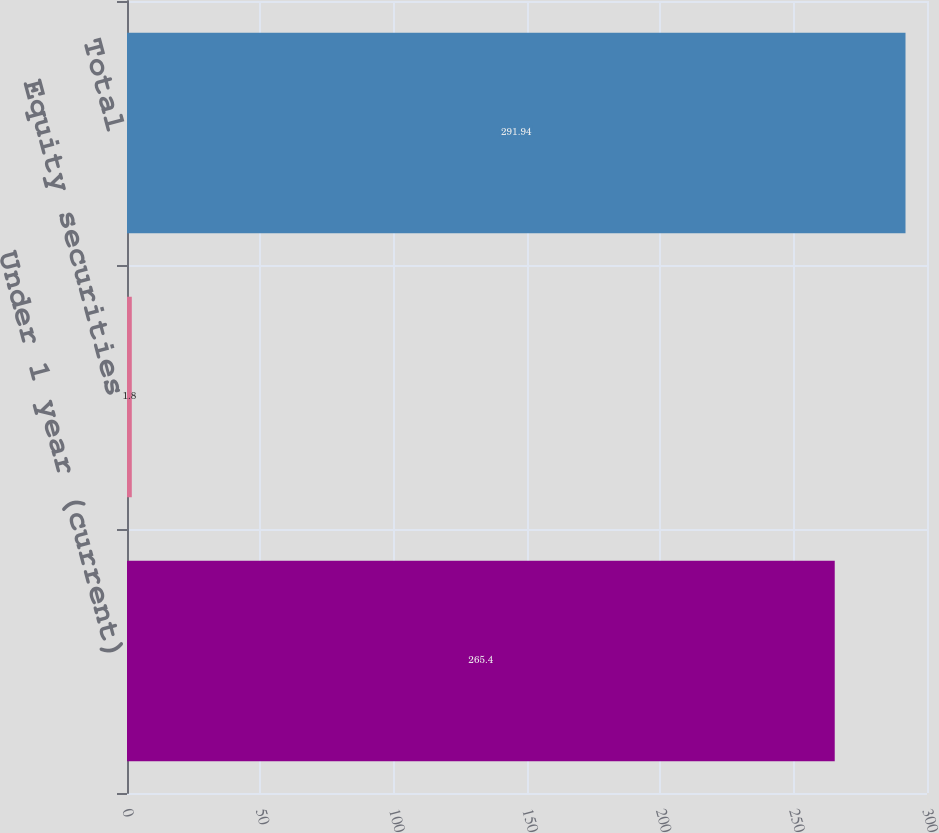Convert chart. <chart><loc_0><loc_0><loc_500><loc_500><bar_chart><fcel>Under 1 year (current)<fcel>Equity securities<fcel>Total<nl><fcel>265.4<fcel>1.8<fcel>291.94<nl></chart> 